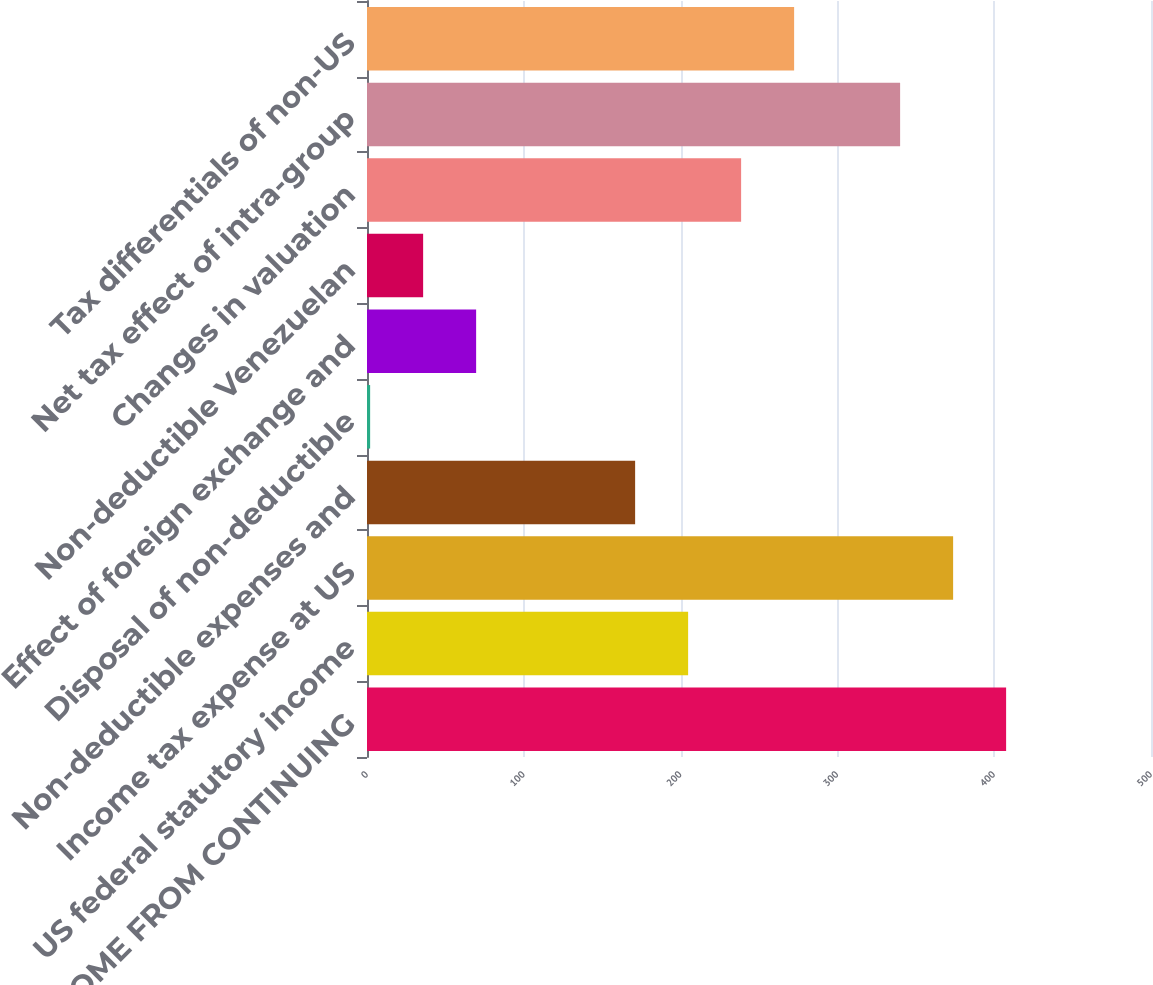Convert chart. <chart><loc_0><loc_0><loc_500><loc_500><bar_chart><fcel>INCOME FROM CONTINUING<fcel>US federal statutory income<fcel>Income tax expense at US<fcel>Non-deductible expenses and<fcel>Disposal of non-deductible<fcel>Effect of foreign exchange and<fcel>Non-deductible Venezuelan<fcel>Changes in valuation<fcel>Net tax effect of intra-group<fcel>Tax differentials of non-US<nl><fcel>407.6<fcel>204.8<fcel>373.8<fcel>171<fcel>2<fcel>69.6<fcel>35.8<fcel>238.6<fcel>340<fcel>272.4<nl></chart> 